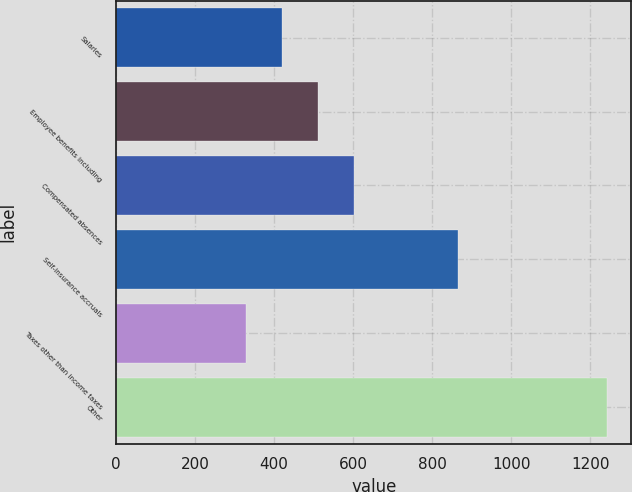Convert chart to OTSL. <chart><loc_0><loc_0><loc_500><loc_500><bar_chart><fcel>Salaries<fcel>Employee benefits including<fcel>Compensated absences<fcel>Self-insurance accruals<fcel>Taxes other than income taxes<fcel>Other<nl><fcel>419.4<fcel>510.8<fcel>602.2<fcel>865<fcel>328<fcel>1242<nl></chart> 